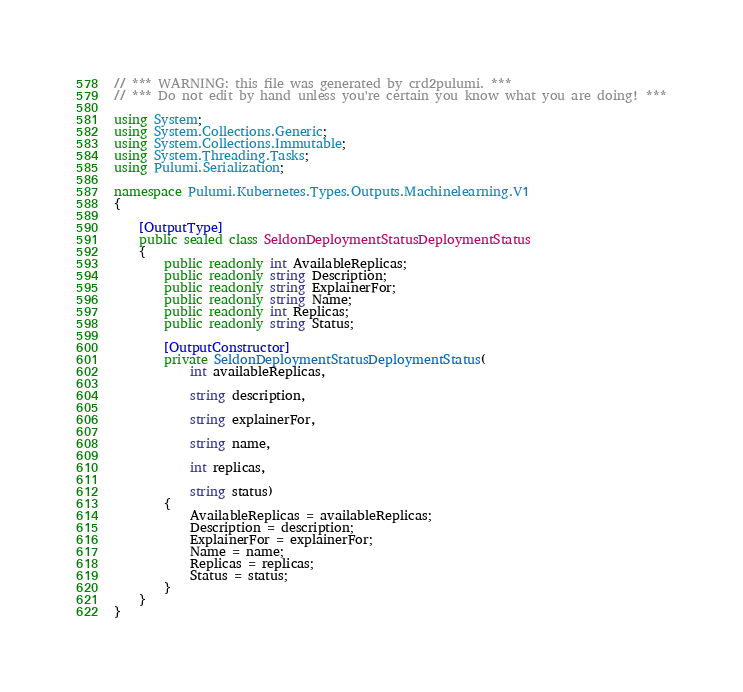<code> <loc_0><loc_0><loc_500><loc_500><_C#_>// *** WARNING: this file was generated by crd2pulumi. ***
// *** Do not edit by hand unless you're certain you know what you are doing! ***

using System;
using System.Collections.Generic;
using System.Collections.Immutable;
using System.Threading.Tasks;
using Pulumi.Serialization;

namespace Pulumi.Kubernetes.Types.Outputs.Machinelearning.V1
{

    [OutputType]
    public sealed class SeldonDeploymentStatusDeploymentStatus
    {
        public readonly int AvailableReplicas;
        public readonly string Description;
        public readonly string ExplainerFor;
        public readonly string Name;
        public readonly int Replicas;
        public readonly string Status;

        [OutputConstructor]
        private SeldonDeploymentStatusDeploymentStatus(
            int availableReplicas,

            string description,

            string explainerFor,

            string name,

            int replicas,

            string status)
        {
            AvailableReplicas = availableReplicas;
            Description = description;
            ExplainerFor = explainerFor;
            Name = name;
            Replicas = replicas;
            Status = status;
        }
    }
}
</code> 